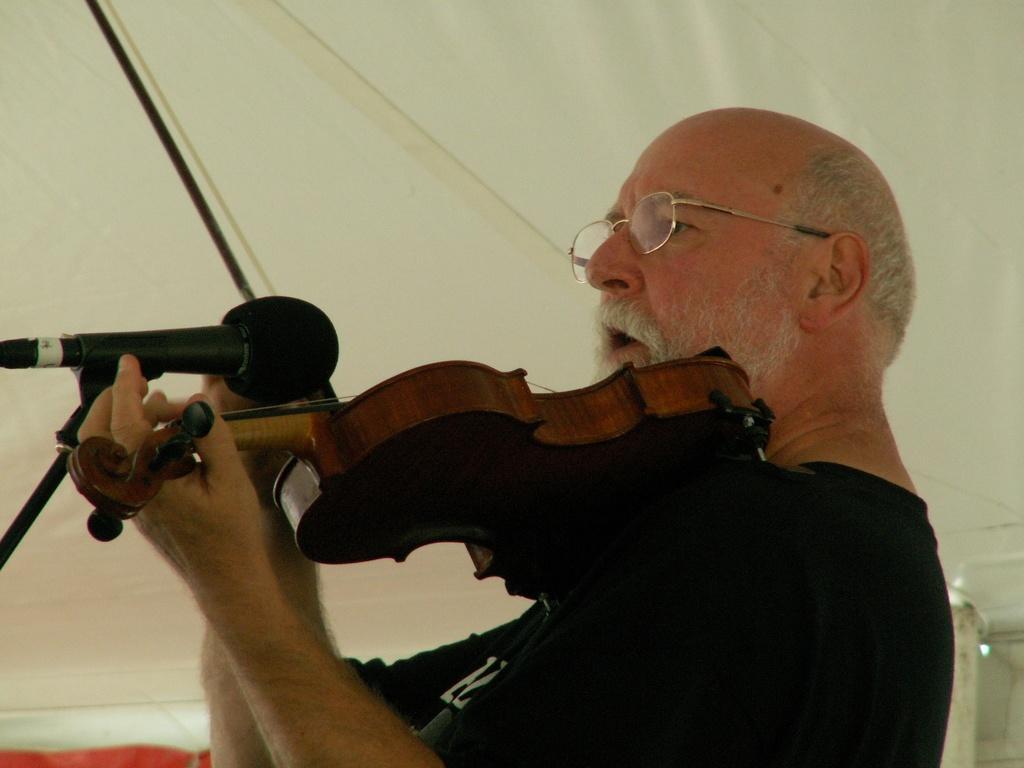How would you summarize this image in a sentence or two? There is a man playing guitar. He wear spectacles and a T-Shirt this is the microphone. He opened his mouth 